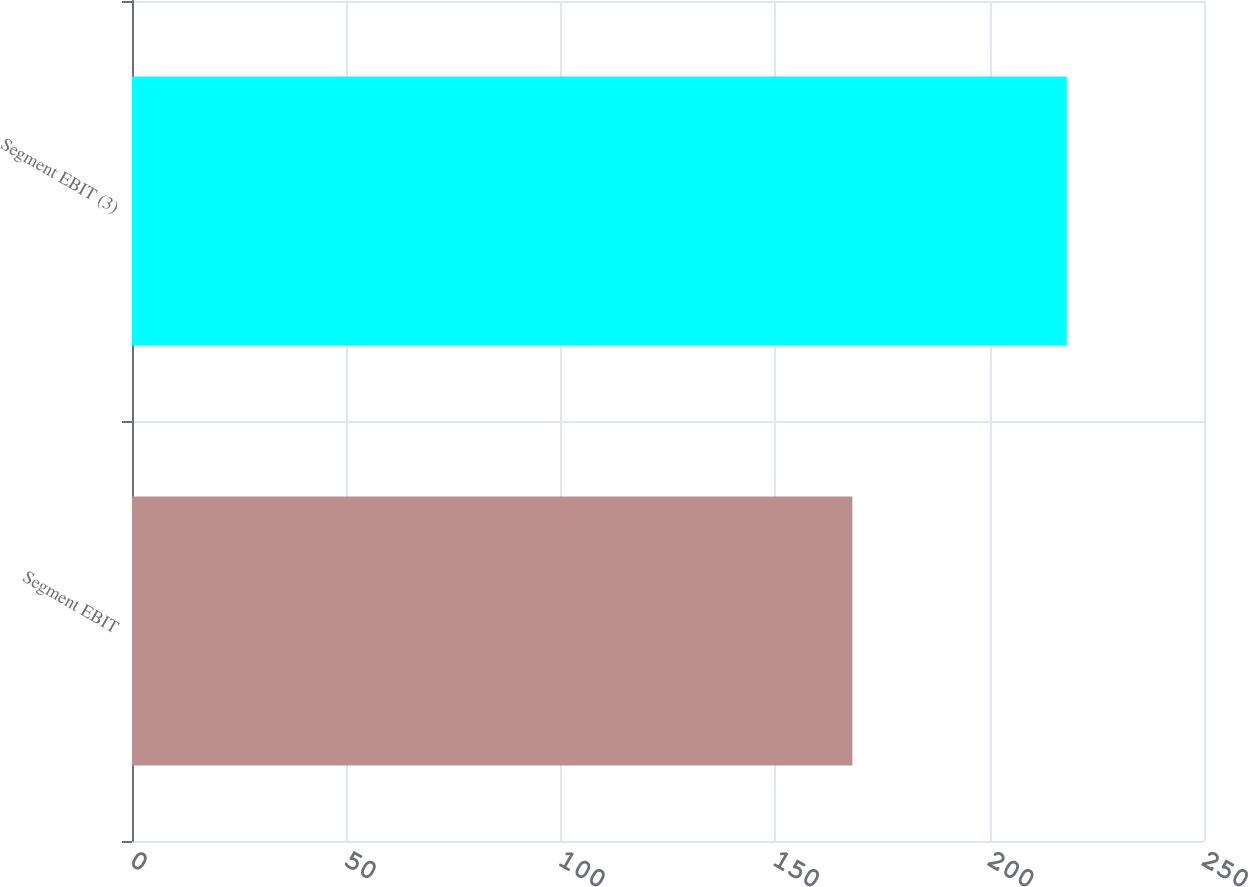<chart> <loc_0><loc_0><loc_500><loc_500><bar_chart><fcel>Segment EBIT<fcel>Segment EBIT (3)<nl><fcel>168<fcel>218<nl></chart> 